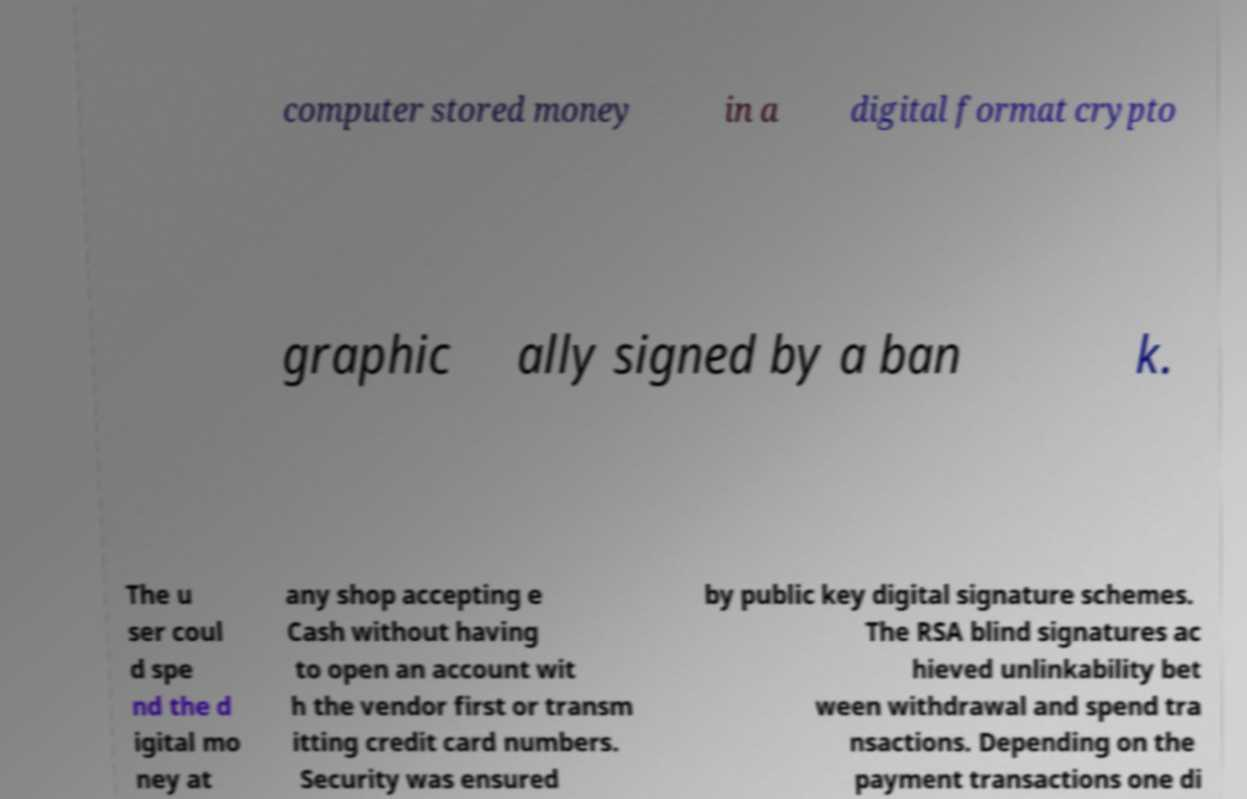Please identify and transcribe the text found in this image. computer stored money in a digital format crypto graphic ally signed by a ban k. The u ser coul d spe nd the d igital mo ney at any shop accepting e Cash without having to open an account wit h the vendor first or transm itting credit card numbers. Security was ensured by public key digital signature schemes. The RSA blind signatures ac hieved unlinkability bet ween withdrawal and spend tra nsactions. Depending on the payment transactions one di 